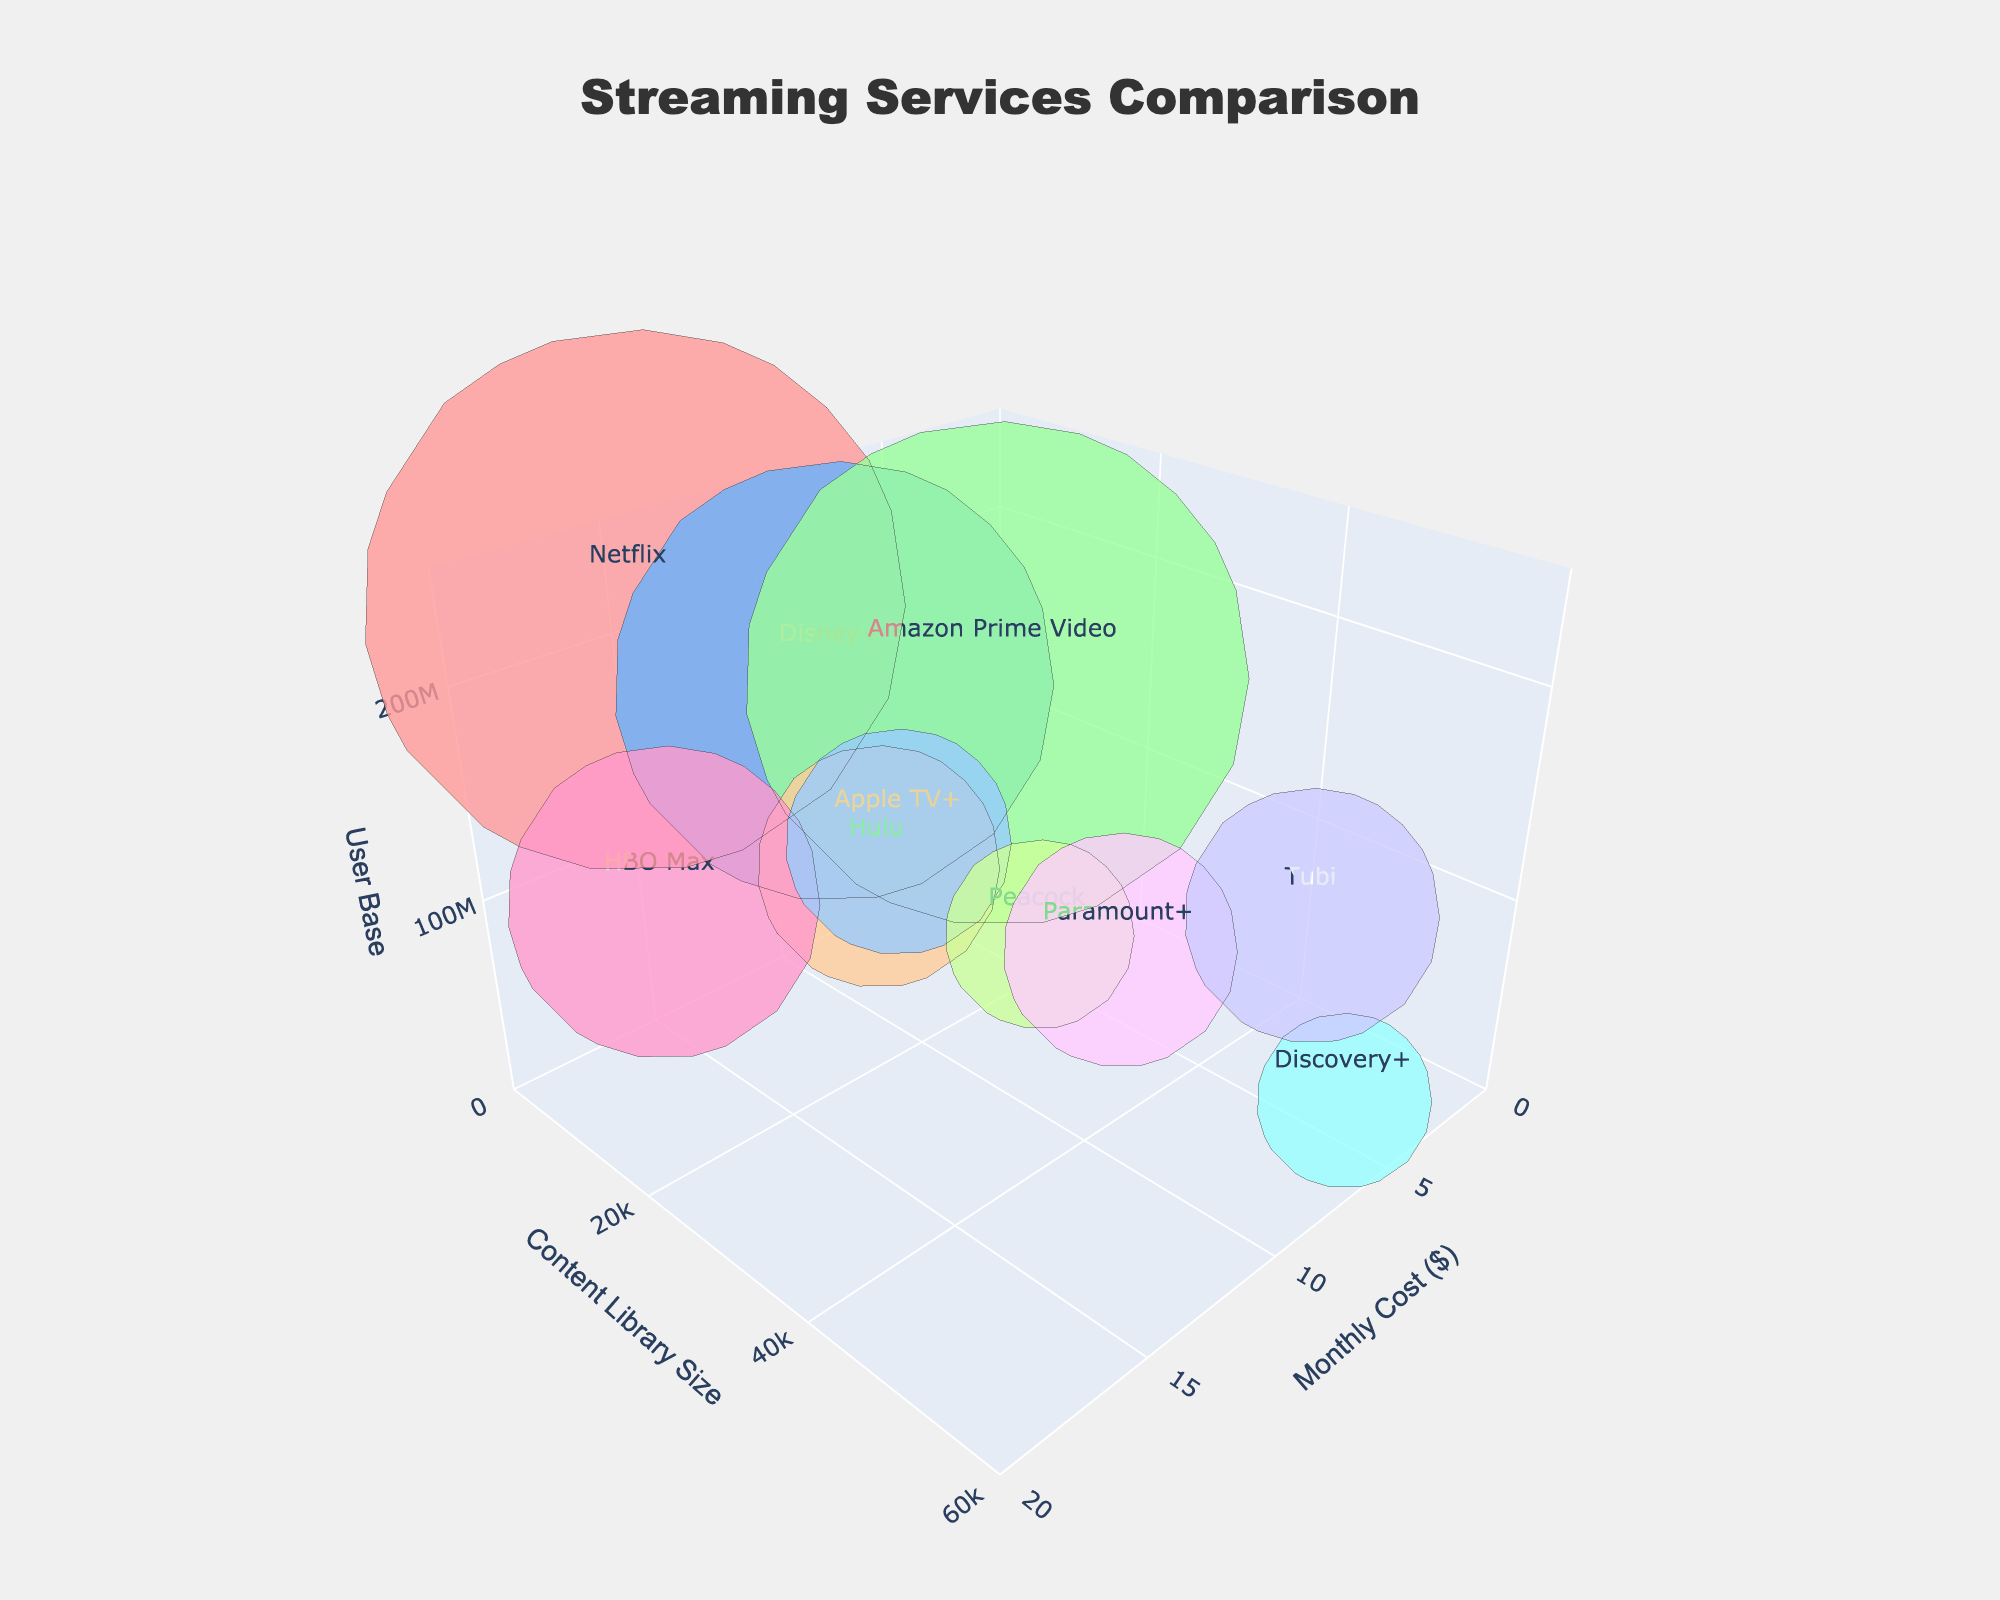What is the monthly cost for Disney+? Locate Disney+ on the figure, find its position on the Monthly Cost axis. Disney+ costs $7.99 per month.
Answer: $7.99 Which streaming service has the highest user base? Identify which bubble reaches the highest point on the User Base axis. Netflix is at the topmost position with 231,000,000 users.
Answer: Netflix Which service offers the largest content library? Observe which bubble is farthest along the Content Library Size axis. Discovery+ has the largest content library with 55,000 titles.
Answer: Discovery+ What is the cheapest streaming service? Determine which bubble is closest to zero on the Monthly Cost axis. Tubi is free, with a monthly cost of $0.
Answer: Tubi Among services costing $4.99, which one has the largest user base? Compare the bubbles for services with a monthly cost of $4.99 and look at their heights (user base). Paramount+ has the largest user base among these services with 43,000,000 users.
Answer: Paramount+ Compare the content library size of Hulu and Amazon Prime Video. Which one is larger? Locate the bubbles for Hulu and Amazon Prime Video and compare their positions on the Content Library Size axis. Amazon Prime Video's library size at 26,000 is larger.
Answer: Amazon Prime Video What is the user base difference between Netflix and Apple TV+? Note the user bases for Netflix (231,000,000) and Apple TV+ (40,000,000) and find their difference. The difference is 191,000,000 users.
Answer: 191,000,000 For services with a monthly cost greater than $10, which one has the smallest user base? Identify the bubbles for services with monthly costs above $10 and compare their heights. HBO Max has the smallest user base at 76,800,000 users.
Answer: HBO Max Which streaming services have a monthly cost under $5, and what are their relative user bases? Identify the bubbles with monthly costs under $5 and compare their heights on the User Base axis. Apple TV+ (40,000,000), Peacock (28,000,000), Paramount+ (43,000,000), Discovery+ (24,000,000), and Tubi (51,000,000) are under $5. Tubi has the largest user base among them.
Answer: Tubi has the largest user base How do the user bases of Netflix and Amazon Prime Video compare? Locate the bubbles for Netflix and Amazon Prime Video and observe their heights on the User Base axis. Netflix's user base (231,000,000) is larger than Amazon Prime Video's (200,000,000).
Answer: Netflix has a larger user base 